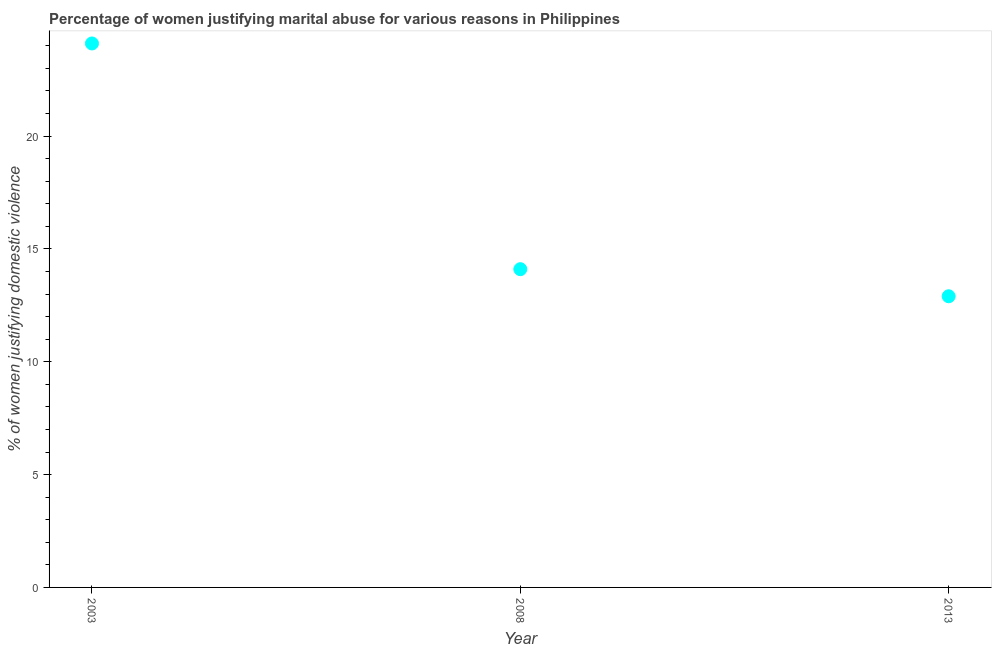What is the percentage of women justifying marital abuse in 2003?
Offer a terse response. 24.1. Across all years, what is the maximum percentage of women justifying marital abuse?
Offer a very short reply. 24.1. Across all years, what is the minimum percentage of women justifying marital abuse?
Keep it short and to the point. 12.9. In which year was the percentage of women justifying marital abuse maximum?
Keep it short and to the point. 2003. In which year was the percentage of women justifying marital abuse minimum?
Keep it short and to the point. 2013. What is the sum of the percentage of women justifying marital abuse?
Ensure brevity in your answer.  51.1. What is the difference between the percentage of women justifying marital abuse in 2003 and 2008?
Your answer should be very brief. 10. What is the average percentage of women justifying marital abuse per year?
Provide a succinct answer. 17.03. What is the median percentage of women justifying marital abuse?
Give a very brief answer. 14.1. In how many years, is the percentage of women justifying marital abuse greater than 18 %?
Your response must be concise. 1. What is the ratio of the percentage of women justifying marital abuse in 2003 to that in 2008?
Your answer should be very brief. 1.71. Is the percentage of women justifying marital abuse in 2003 less than that in 2008?
Provide a succinct answer. No. What is the difference between the highest and the second highest percentage of women justifying marital abuse?
Provide a short and direct response. 10. Is the sum of the percentage of women justifying marital abuse in 2003 and 2013 greater than the maximum percentage of women justifying marital abuse across all years?
Your answer should be compact. Yes. What is the difference between the highest and the lowest percentage of women justifying marital abuse?
Provide a short and direct response. 11.2. How many dotlines are there?
Keep it short and to the point. 1. What is the difference between two consecutive major ticks on the Y-axis?
Your answer should be very brief. 5. Are the values on the major ticks of Y-axis written in scientific E-notation?
Ensure brevity in your answer.  No. Does the graph contain any zero values?
Your response must be concise. No. What is the title of the graph?
Your answer should be very brief. Percentage of women justifying marital abuse for various reasons in Philippines. What is the label or title of the Y-axis?
Provide a succinct answer. % of women justifying domestic violence. What is the % of women justifying domestic violence in 2003?
Your answer should be compact. 24.1. What is the difference between the % of women justifying domestic violence in 2003 and 2013?
Provide a succinct answer. 11.2. What is the ratio of the % of women justifying domestic violence in 2003 to that in 2008?
Make the answer very short. 1.71. What is the ratio of the % of women justifying domestic violence in 2003 to that in 2013?
Your response must be concise. 1.87. What is the ratio of the % of women justifying domestic violence in 2008 to that in 2013?
Give a very brief answer. 1.09. 